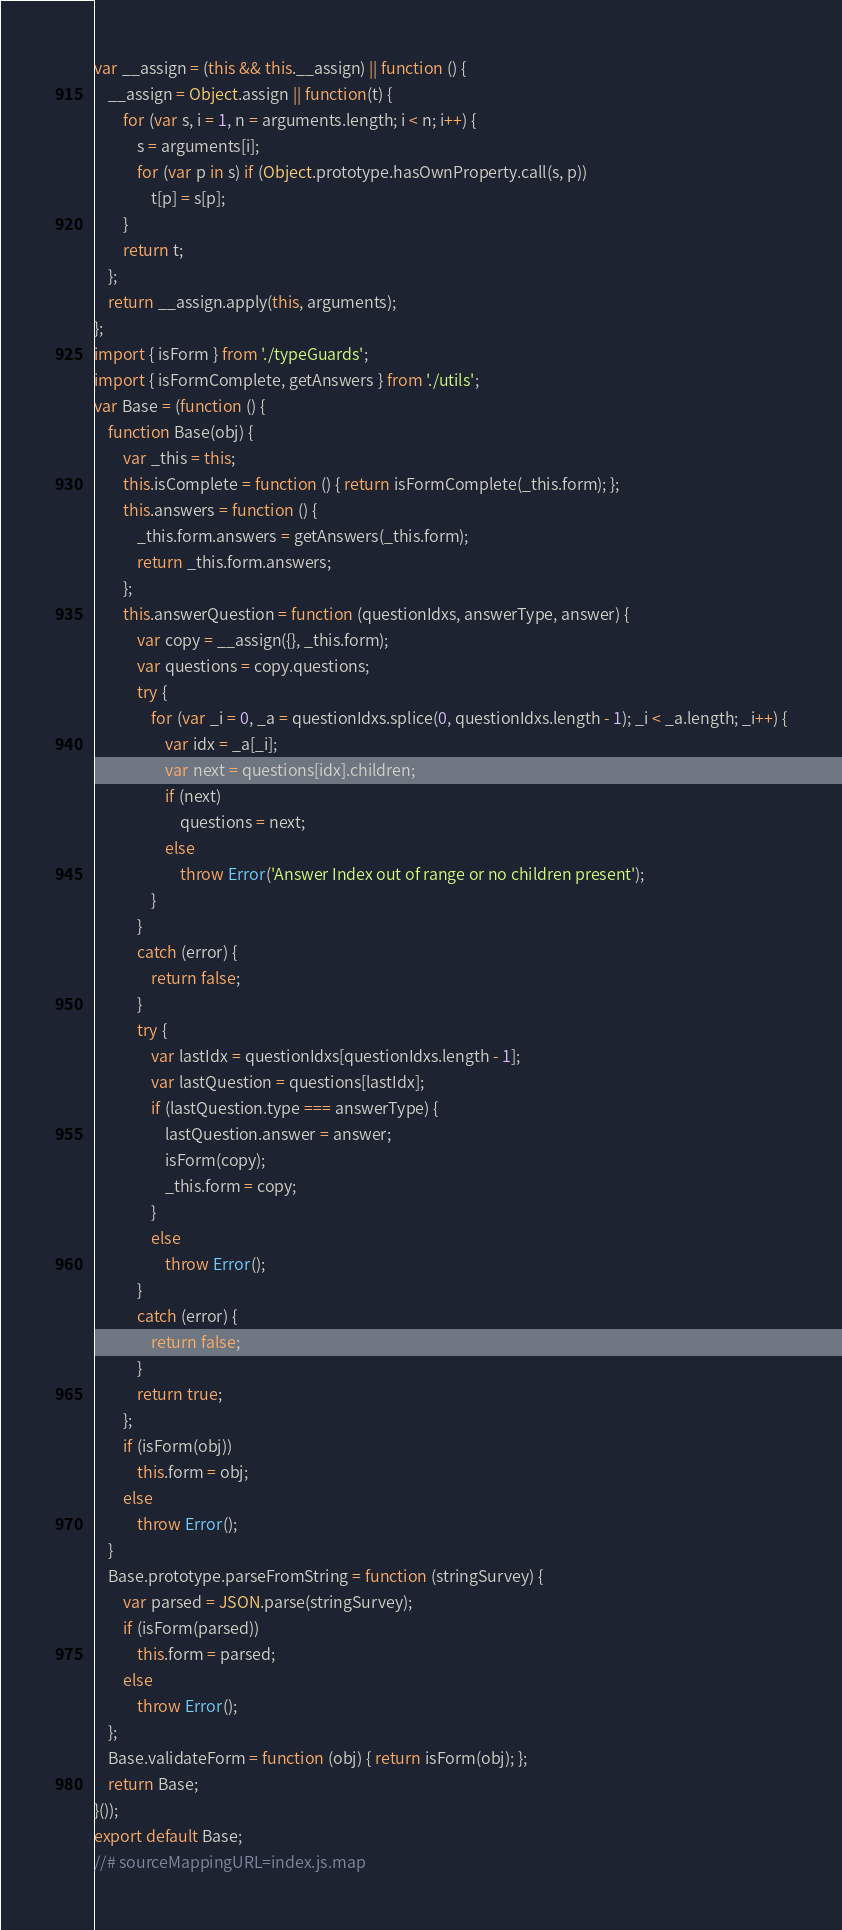<code> <loc_0><loc_0><loc_500><loc_500><_JavaScript_>var __assign = (this && this.__assign) || function () {
    __assign = Object.assign || function(t) {
        for (var s, i = 1, n = arguments.length; i < n; i++) {
            s = arguments[i];
            for (var p in s) if (Object.prototype.hasOwnProperty.call(s, p))
                t[p] = s[p];
        }
        return t;
    };
    return __assign.apply(this, arguments);
};
import { isForm } from './typeGuards';
import { isFormComplete, getAnswers } from './utils';
var Base = (function () {
    function Base(obj) {
        var _this = this;
        this.isComplete = function () { return isFormComplete(_this.form); };
        this.answers = function () {
            _this.form.answers = getAnswers(_this.form);
            return _this.form.answers;
        };
        this.answerQuestion = function (questionIdxs, answerType, answer) {
            var copy = __assign({}, _this.form);
            var questions = copy.questions;
            try {
                for (var _i = 0, _a = questionIdxs.splice(0, questionIdxs.length - 1); _i < _a.length; _i++) {
                    var idx = _a[_i];
                    var next = questions[idx].children;
                    if (next)
                        questions = next;
                    else
                        throw Error('Answer Index out of range or no children present');
                }
            }
            catch (error) {
                return false;
            }
            try {
                var lastIdx = questionIdxs[questionIdxs.length - 1];
                var lastQuestion = questions[lastIdx];
                if (lastQuestion.type === answerType) {
                    lastQuestion.answer = answer;
                    isForm(copy);
                    _this.form = copy;
                }
                else
                    throw Error();
            }
            catch (error) {
                return false;
            }
            return true;
        };
        if (isForm(obj))
            this.form = obj;
        else
            throw Error();
    }
    Base.prototype.parseFromString = function (stringSurvey) {
        var parsed = JSON.parse(stringSurvey);
        if (isForm(parsed))
            this.form = parsed;
        else
            throw Error();
    };
    Base.validateForm = function (obj) { return isForm(obj); };
    return Base;
}());
export default Base;
//# sourceMappingURL=index.js.map</code> 